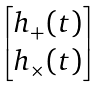<formula> <loc_0><loc_0><loc_500><loc_500>\begin{bmatrix} h _ { + } ( t ) \\ h _ { \times } ( t ) \end{bmatrix}</formula> 